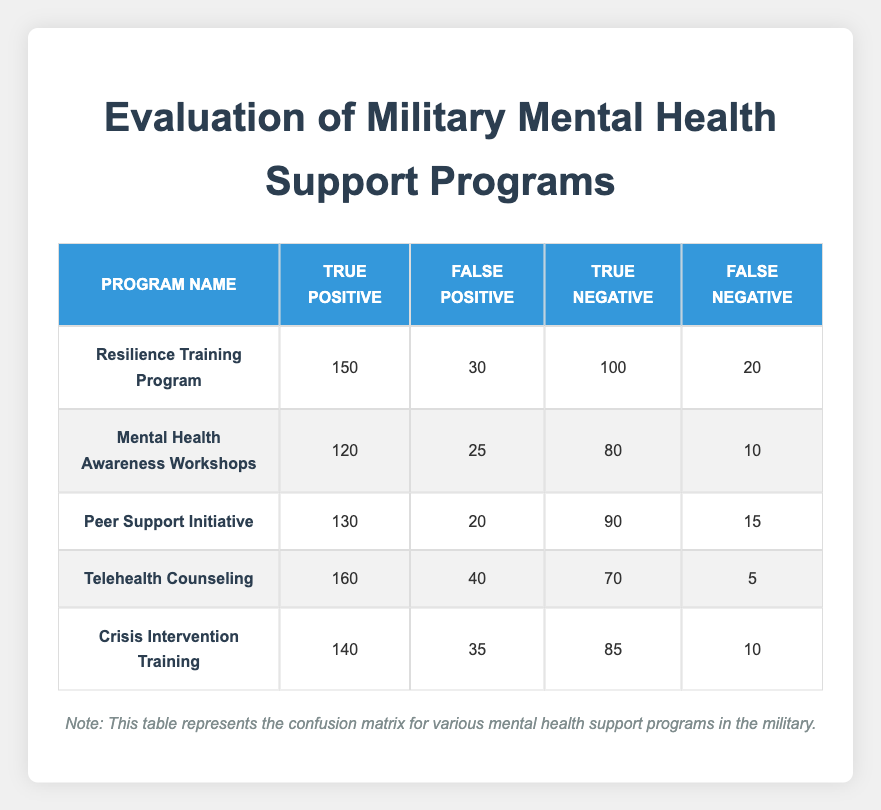What is the True Positive count for the Telehealth Counseling program? In the table, find the row corresponding to the Telehealth Counseling program. The True Positive count is listed directly as 160.
Answer: 160 Which program has the highest number of False Positives? Looking through the False Positive column, compare the values. The Telehealth Counseling program has 40, which is higher than all other programs.
Answer: Telehealth Counseling What is the total number of True Negatives across all programs? The True Negatives are 100, 80, 90, 70, and 85 for the respective programs. Adding these values gives: 100 + 80 + 90 + 70 + 85 = 425.
Answer: 425 Is the number of True Positives for the Peer Support Initiative greater than that for the Mental Health Awareness Workshops? Comparing the True Positive counts, Peer Support Initiative has 130 and Mental Health Awareness Workshops has 120. Since 130 is greater than 120, the statement is true.
Answer: Yes What is the average number of False Negatives across all programs? The False Negatives are 20, 10, 15, 5, and 10 respectively. Summing these gives 20 + 10 + 15 + 5 + 10 = 70, then dividing by the number of programs (5) gives 70 / 5 = 14.
Answer: 14 Which program has the lowest True Negative count? Reviewing the True Negative column, the program with the lowest count is the Telehealth Counseling program with a score of 70.
Answer: Telehealth Counseling How many total True Positives and True Negatives do the Crisis Intervention Training program account for? The True Positives for Crisis Intervention Training is 140 and True Negatives is 85. Adding these values gives a total of 140 + 85 = 225.
Answer: 225 Does the Mental Health Awareness Workshops have more False Negatives than the Resilience Training Program? The False Negatives for Mental Health Awareness Workshops is 10, while for Resilience Training Program it is 20. Since 10 is less than 20, the statement is false.
Answer: No What is the difference in True Positives between the Resilience Training Program and the Peer Support Initiative? The True Positives for Resilience Training is 150 and for Peer Support Initiative is 130. The difference is 150 - 130 = 20.
Answer: 20 